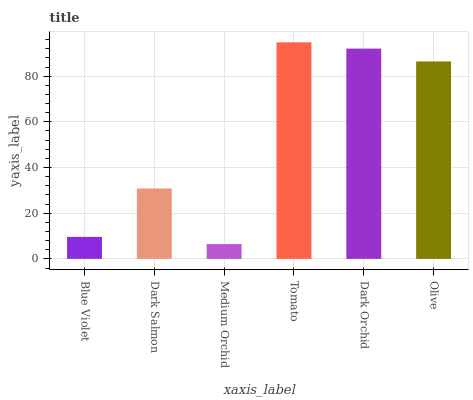Is Medium Orchid the minimum?
Answer yes or no. Yes. Is Tomato the maximum?
Answer yes or no. Yes. Is Dark Salmon the minimum?
Answer yes or no. No. Is Dark Salmon the maximum?
Answer yes or no. No. Is Dark Salmon greater than Blue Violet?
Answer yes or no. Yes. Is Blue Violet less than Dark Salmon?
Answer yes or no. Yes. Is Blue Violet greater than Dark Salmon?
Answer yes or no. No. Is Dark Salmon less than Blue Violet?
Answer yes or no. No. Is Olive the high median?
Answer yes or no. Yes. Is Dark Salmon the low median?
Answer yes or no. Yes. Is Dark Orchid the high median?
Answer yes or no. No. Is Medium Orchid the low median?
Answer yes or no. No. 